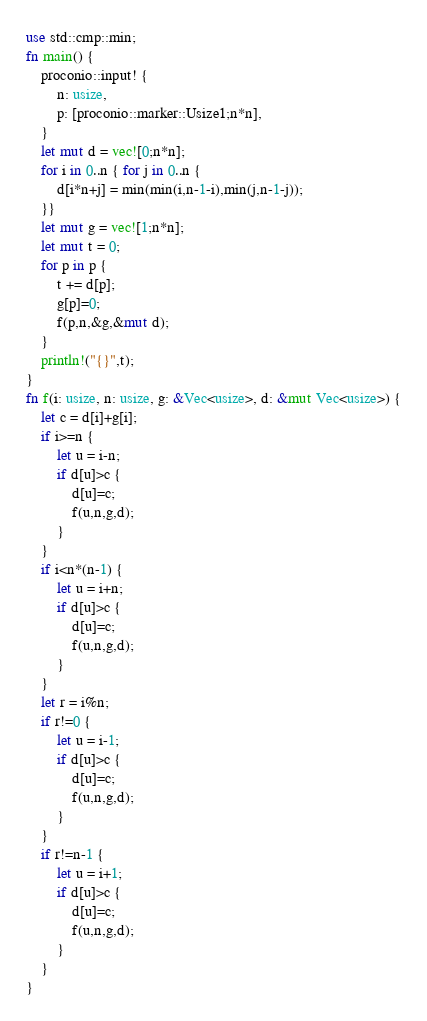<code> <loc_0><loc_0><loc_500><loc_500><_Rust_>use std::cmp::min;
fn main() {
    proconio::input! {
        n: usize,
        p: [proconio::marker::Usize1;n*n],
    }
    let mut d = vec![0;n*n];
    for i in 0..n { for j in 0..n {
        d[i*n+j] = min(min(i,n-1-i),min(j,n-1-j));
    }}
    let mut g = vec![1;n*n];
    let mut t = 0;
    for p in p {
        t += d[p];
        g[p]=0;
        f(p,n,&g,&mut d);
    }
    println!("{}",t);
}
fn f(i: usize, n: usize, g: &Vec<usize>, d: &mut Vec<usize>) {
    let c = d[i]+g[i];
    if i>=n {
        let u = i-n;
        if d[u]>c {
            d[u]=c;
            f(u,n,g,d);
        }
    }
    if i<n*(n-1) {
        let u = i+n;
        if d[u]>c {
            d[u]=c;
            f(u,n,g,d);
        }
    }
    let r = i%n;
    if r!=0 {
        let u = i-1;
        if d[u]>c {
            d[u]=c;
            f(u,n,g,d);
        }
    }
    if r!=n-1 {
        let u = i+1;
        if d[u]>c {
            d[u]=c;
            f(u,n,g,d);
        }
    }
}</code> 